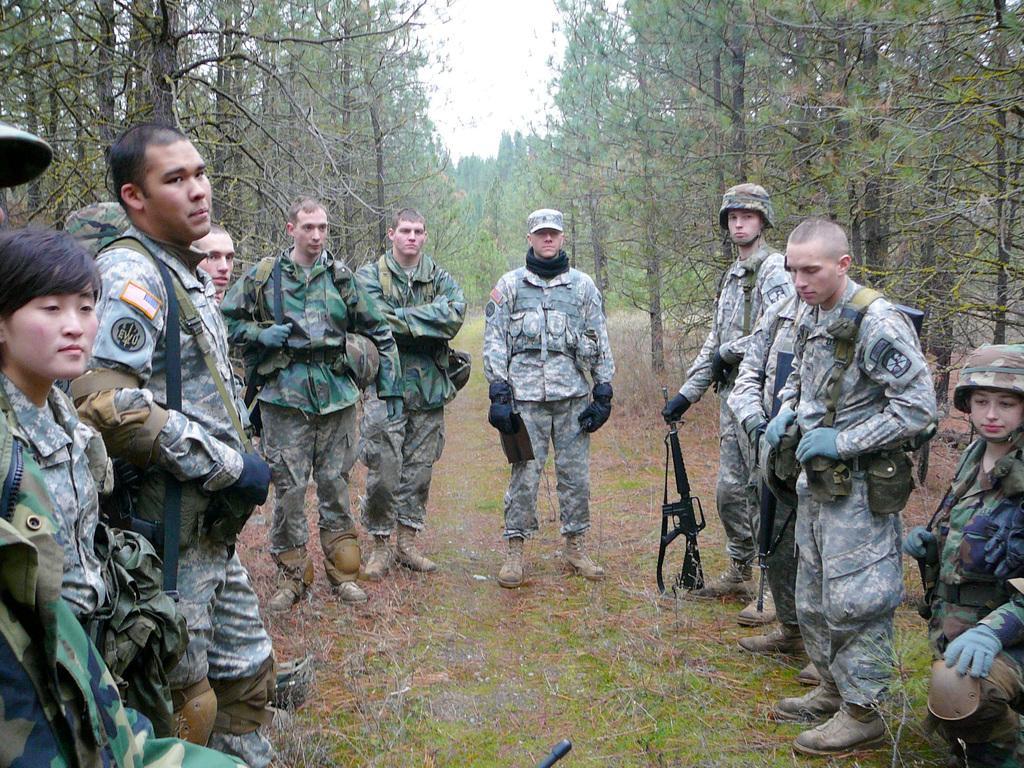Please provide a concise description of this image. In the image is a group of people standing. There are few people with caps on their heads. There is a person holding a gun. On the ground there is grass. In the background there are trees. 